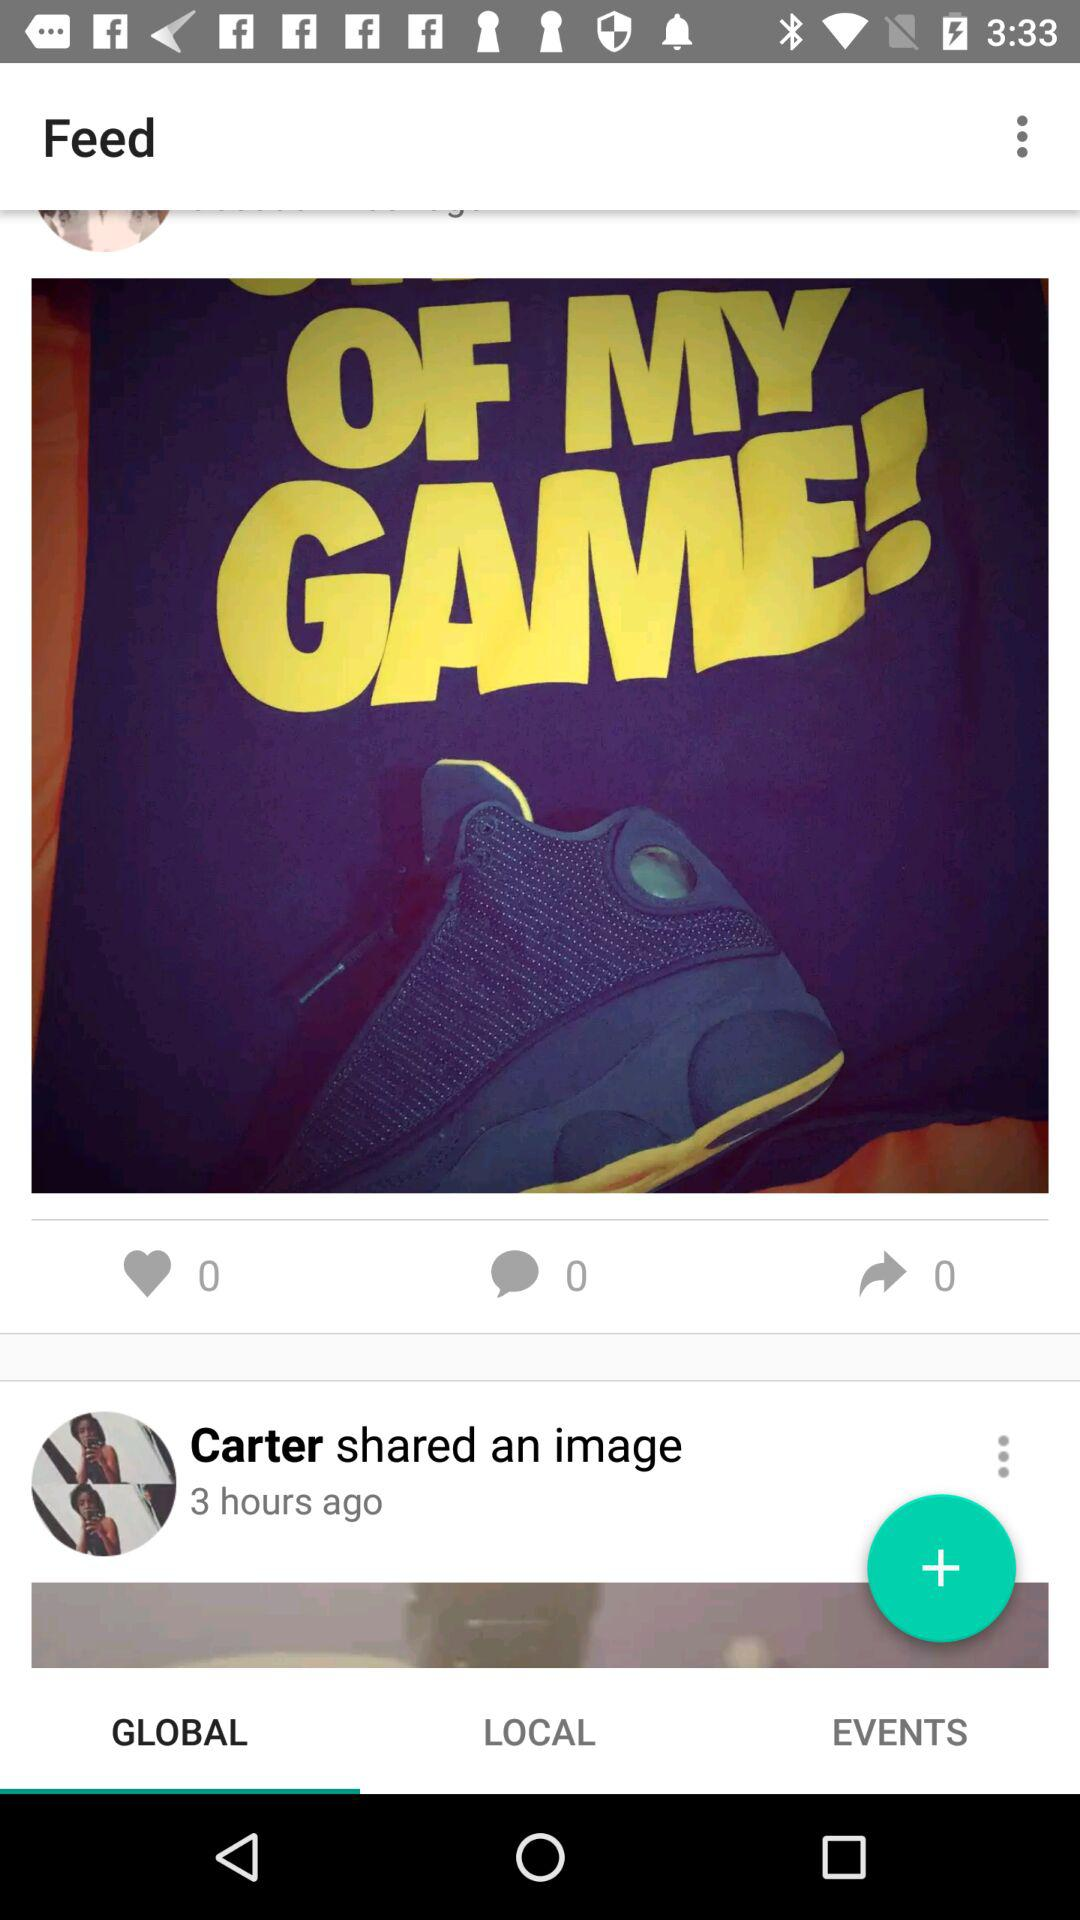How many likes are there on the post? There are 0 likes on the post. 